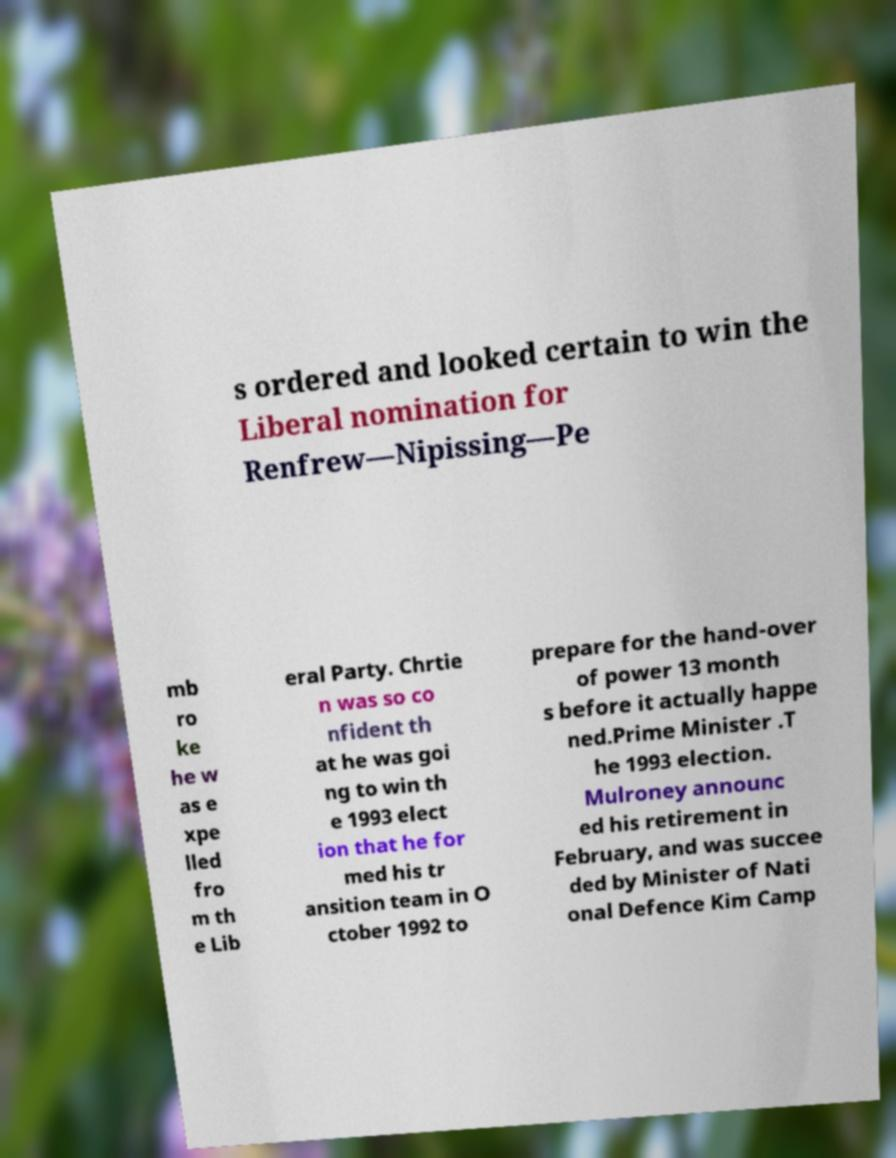Please identify and transcribe the text found in this image. s ordered and looked certain to win the Liberal nomination for Renfrew—Nipissing—Pe mb ro ke he w as e xpe lled fro m th e Lib eral Party. Chrtie n was so co nfident th at he was goi ng to win th e 1993 elect ion that he for med his tr ansition team in O ctober 1992 to prepare for the hand-over of power 13 month s before it actually happe ned.Prime Minister .T he 1993 election. Mulroney announc ed his retirement in February, and was succee ded by Minister of Nati onal Defence Kim Camp 